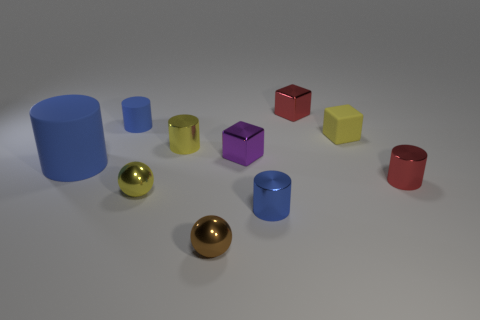There is a metal sphere that is the same color as the matte cube; what is its size? The metal sphere, sharing the rich golden hue of the matte cube, exhibits a small size in comparison to the surrounding geometric forms, likely not surpassing a few centimeters in diameter, enabling a delicate placement amidst an array of diverse and vividly colored shapes. 